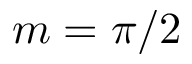<formula> <loc_0><loc_0><loc_500><loc_500>m = \pi / 2</formula> 